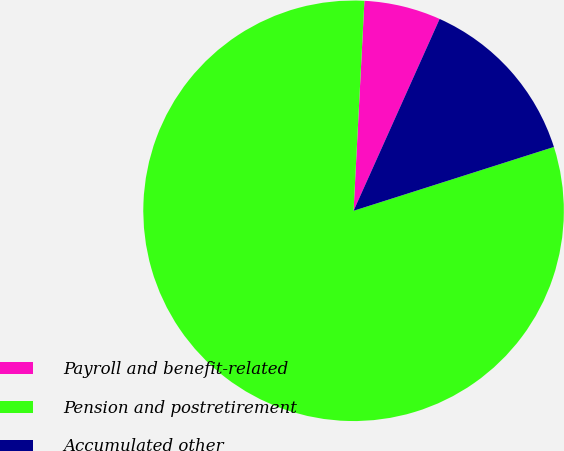Convert chart to OTSL. <chart><loc_0><loc_0><loc_500><loc_500><pie_chart><fcel>Payroll and benefit-related<fcel>Pension and postretirement<fcel>Accumulated other<nl><fcel>5.89%<fcel>80.73%<fcel>13.38%<nl></chart> 